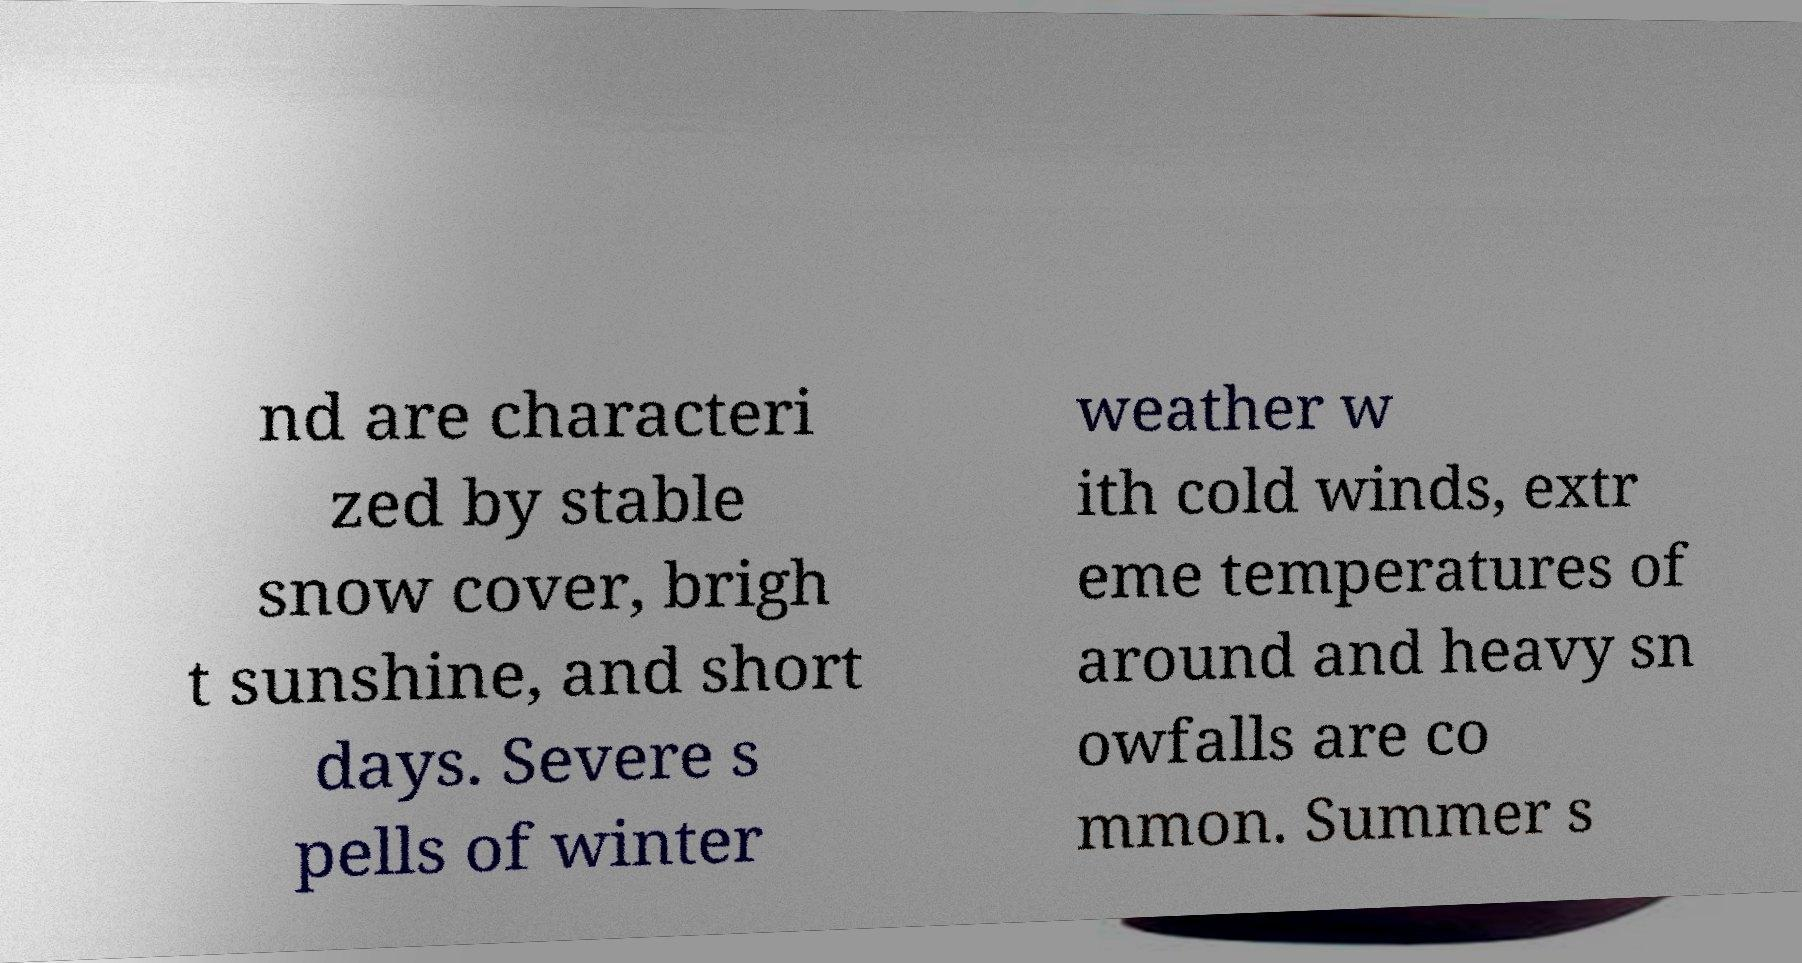Can you accurately transcribe the text from the provided image for me? nd are characteri zed by stable snow cover, brigh t sunshine, and short days. Severe s pells of winter weather w ith cold winds, extr eme temperatures of around and heavy sn owfalls are co mmon. Summer s 